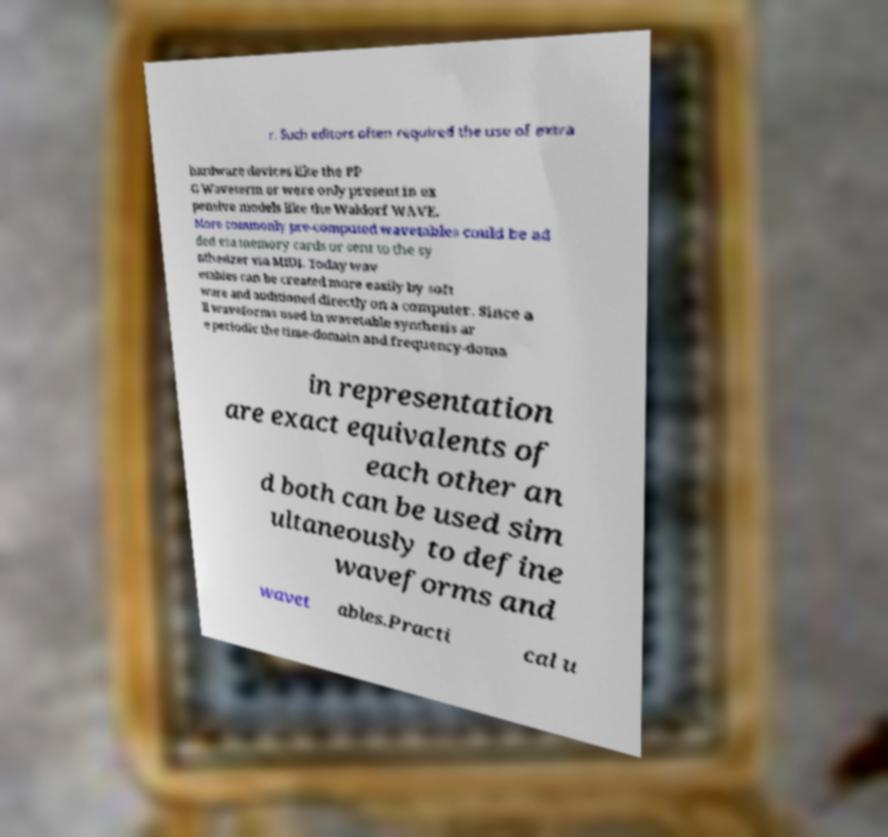There's text embedded in this image that I need extracted. Can you transcribe it verbatim? r. Such editors often required the use of extra hardware devices like the PP G Waveterm or were only present in ex pensive models like the Waldorf WAVE. More commonly pre-computed wavetables could be ad ded via memory cards or sent to the sy nthesizer via MIDI. Today wav etables can be created more easily by soft ware and auditioned directly on a computer. Since a ll waveforms used in wavetable synthesis ar e periodic the time-domain and frequency-doma in representation are exact equivalents of each other an d both can be used sim ultaneously to define waveforms and wavet ables.Practi cal u 